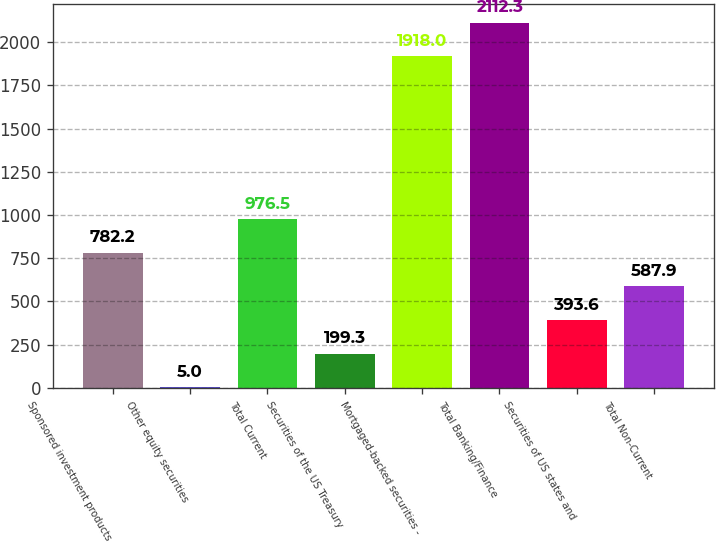<chart> <loc_0><loc_0><loc_500><loc_500><bar_chart><fcel>Sponsored investment products<fcel>Other equity securities<fcel>Total Current<fcel>Securities of the US Treasury<fcel>Mortgaged-backed securities -<fcel>Total Banking/Finance<fcel>Securities of US states and<fcel>Total Non-Current<nl><fcel>782.2<fcel>5<fcel>976.5<fcel>199.3<fcel>1918<fcel>2112.3<fcel>393.6<fcel>587.9<nl></chart> 